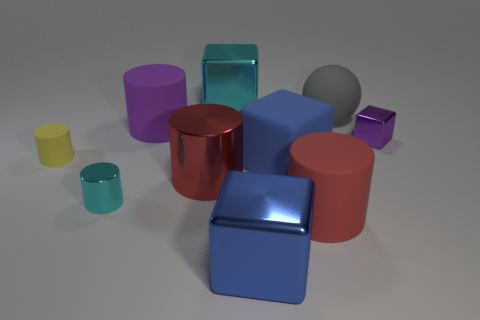Subtract all purple blocks. How many blocks are left? 3 Subtract all red spheres. How many blue cubes are left? 2 Subtract 3 cylinders. How many cylinders are left? 2 Subtract all red cylinders. How many cylinders are left? 3 Subtract all blocks. How many objects are left? 6 Subtract all brown blocks. Subtract all purple spheres. How many blocks are left? 4 Subtract all big red cylinders. Subtract all yellow cylinders. How many objects are left? 7 Add 4 tiny cyan cylinders. How many tiny cyan cylinders are left? 5 Add 10 big brown rubber cubes. How many big brown rubber cubes exist? 10 Subtract 0 red spheres. How many objects are left? 10 